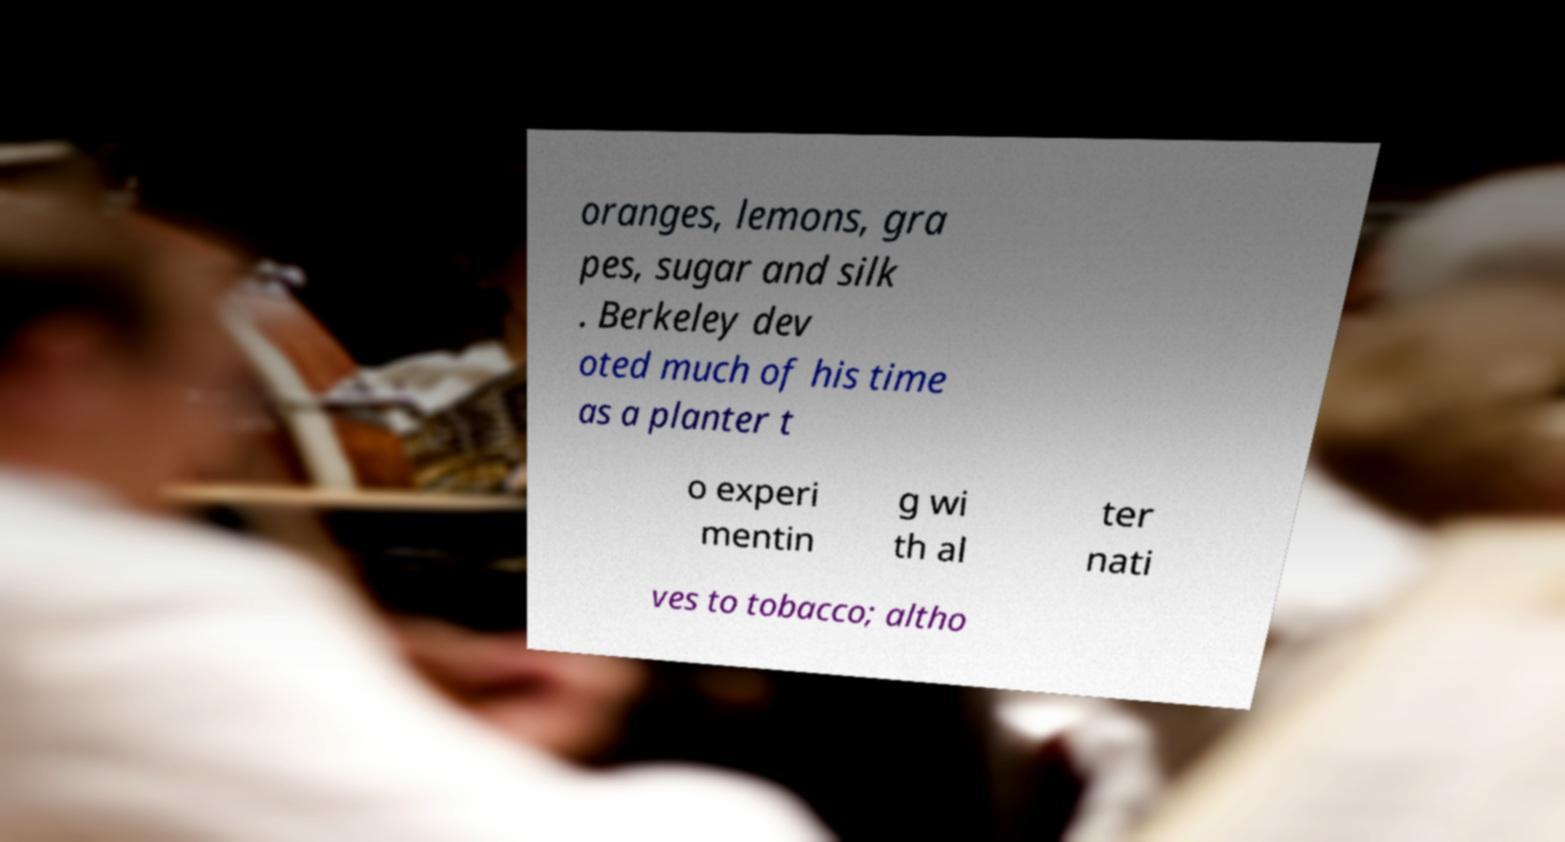Can you read and provide the text displayed in the image?This photo seems to have some interesting text. Can you extract and type it out for me? oranges, lemons, gra pes, sugar and silk . Berkeley dev oted much of his time as a planter t o experi mentin g wi th al ter nati ves to tobacco; altho 